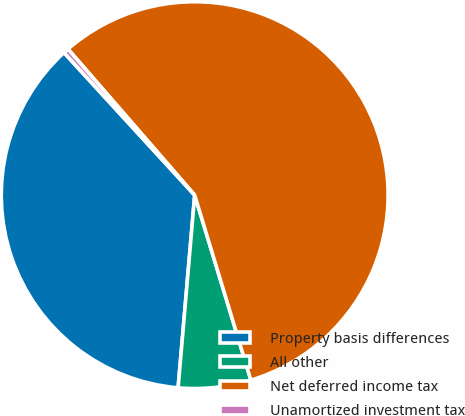Convert chart. <chart><loc_0><loc_0><loc_500><loc_500><pie_chart><fcel>Property basis differences<fcel>All other<fcel>Net deferred income tax<fcel>Unamortized investment tax<nl><fcel>36.82%<fcel>6.06%<fcel>56.68%<fcel>0.44%<nl></chart> 